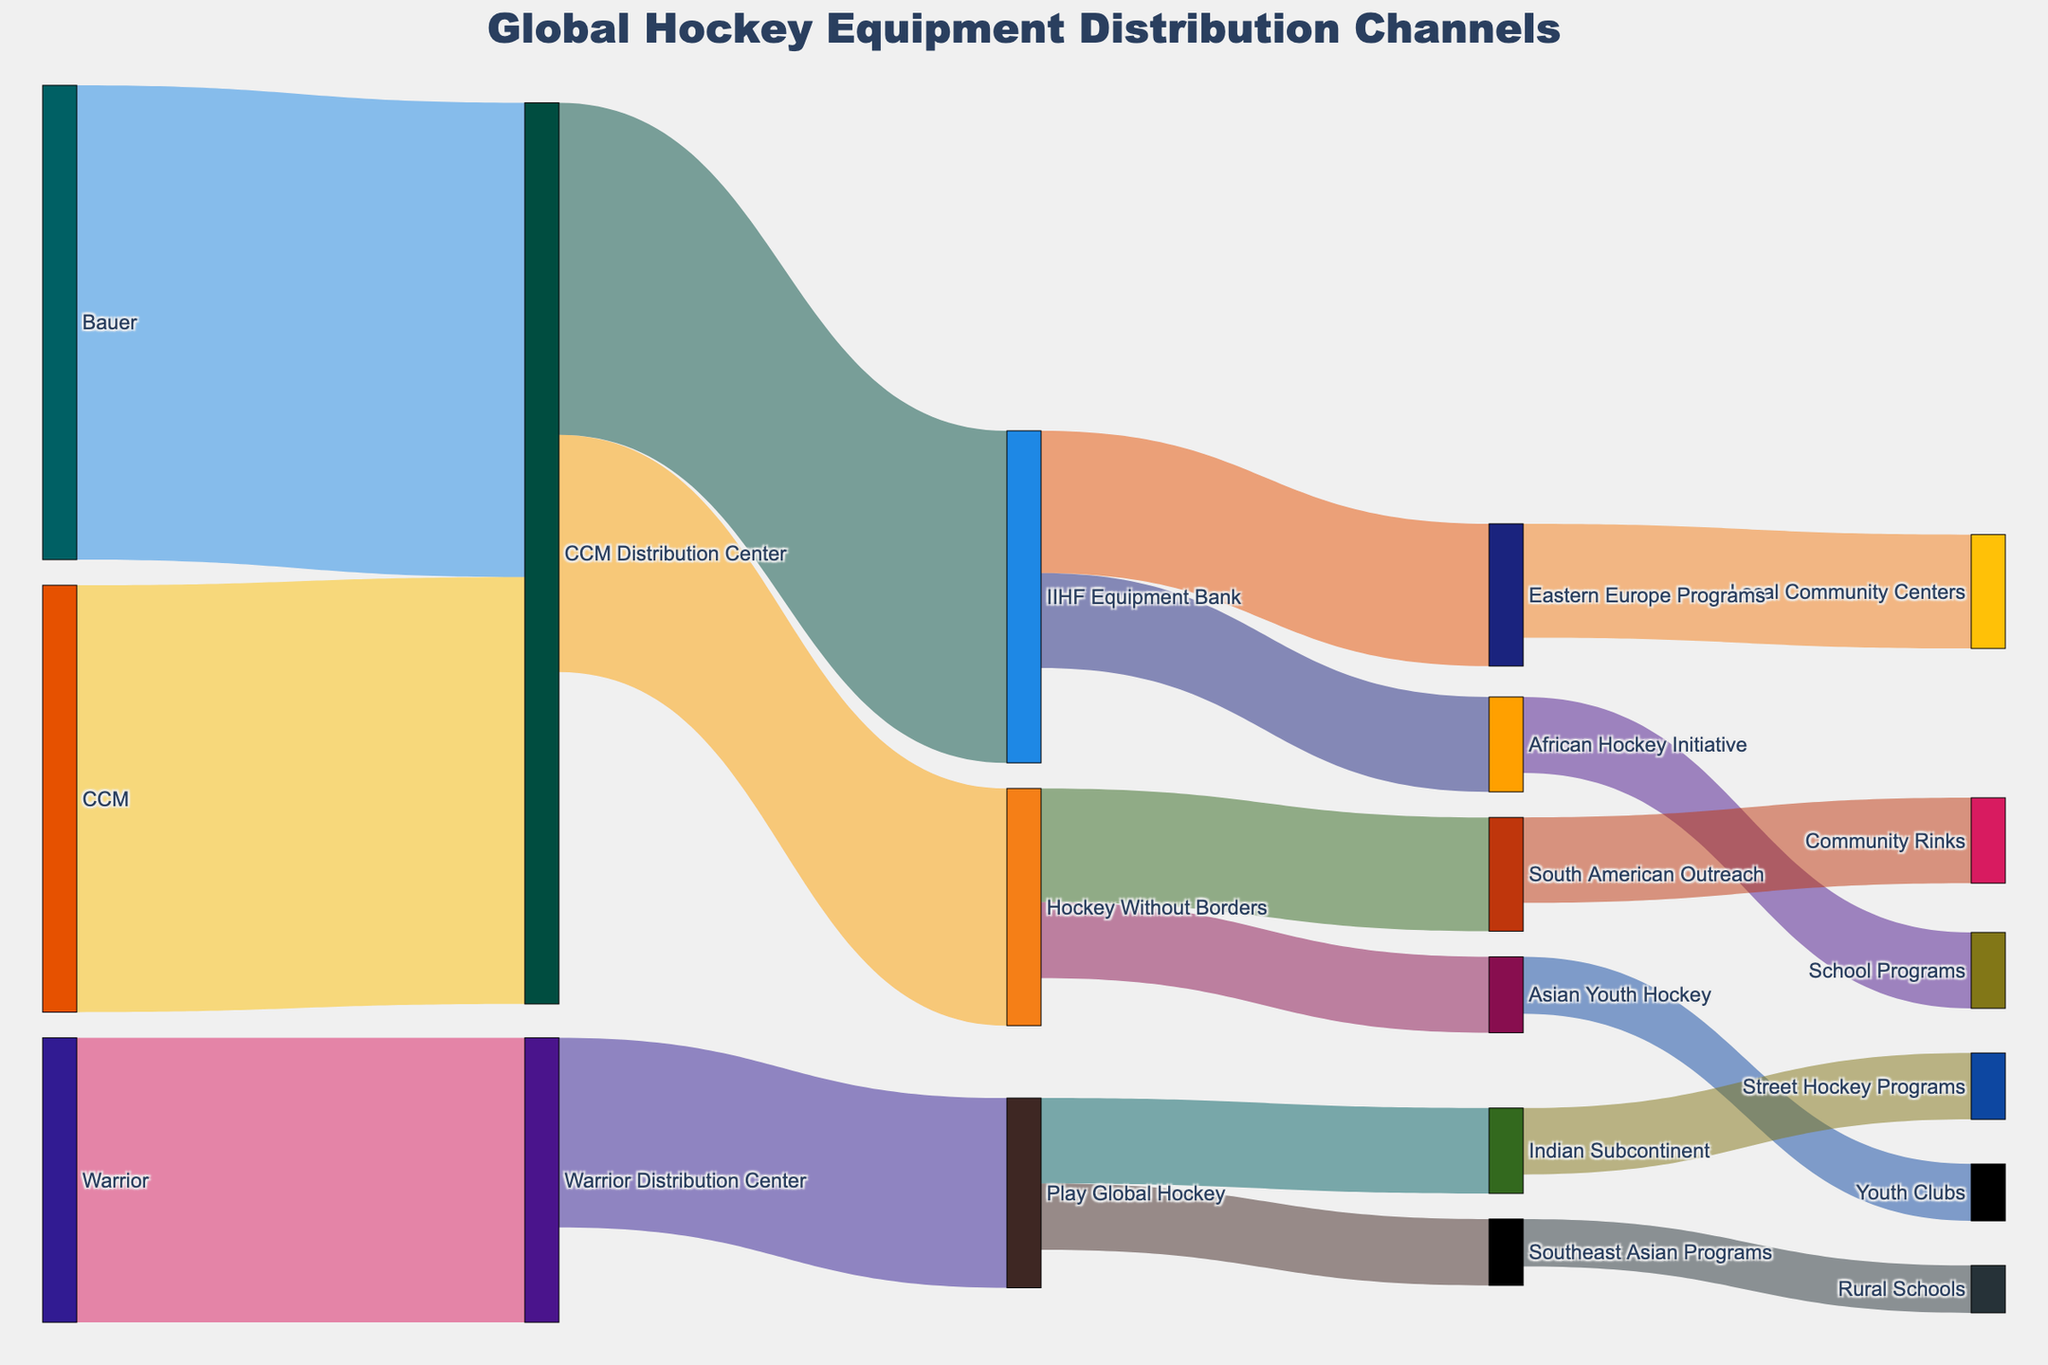Which manufacturer distributes the most equipment to its distribution center? Bauer sends 5000 units to the CCM Distribution Center, CCM sends 4500 units to the CCM Distribution Center, and Warrior sends 3000 units to the Warrior Distribution Center. The highest value is 5000 from Bauer to the CCM Distribution Center.
Answer: Bauer What is the total number of equipment units sent to the Play Global Hockey organization? Play Global Hockey receives 2000 units from Warrior Distribution Center.
Answer: 2000 Which initiative receives the least equipment from the IIHF Equipment Bank? IIHF Equipment Bank sends 1500 units to Eastern Europe Programs and 1000 units to African Hockey Initiative. The least is 1000 to African Hockey Initiative.
Answer: African Hockey Initiative How many units in total are distributed by the CCM Distribution Center? The CCM Distribution Center distributes 3500 units to the IIHF Equipment Bank and 2500 units to Hockey Without Borders, which sums up to 6000 units in total.
Answer: 6000 Which organization sends the most equipment to community or school programs? Eastern Europe Programs send 1200 units to Local Community Centers, African Hockey Initiative sends 800 units to School Programs, South American Outreach sends 900 units to Community Rinks, Asian Youth Hockey sends 600 units to Youth Clubs, Indian Subcontinent sends 700 units to Street Hockey Programs, and Southeast Asian Programs send 500 units to Rural Schools. The highest value is 1200 units from Eastern Europe Programs to Local Community Centers.
Answer: Eastern Europe Programs Compare the equipment distributed by Hockey Without Borders to South American Outreach and Asian Youth Hockey. Which receives more? Hockey Without Borders distributes 1200 units to South American Outreach and 800 units to Asian Youth Hockey. South American Outreach receives more, with 1200 units.
Answer: South American Outreach What is the total equipment received by the Southeast Asian Programs? The Southeast Asian Programs receive 700 units from Play Global Hockey and 500 units are distributed to Rural Schools. Only the 700 units from Play Global Hockey should be counted as received.
Answer: 700 